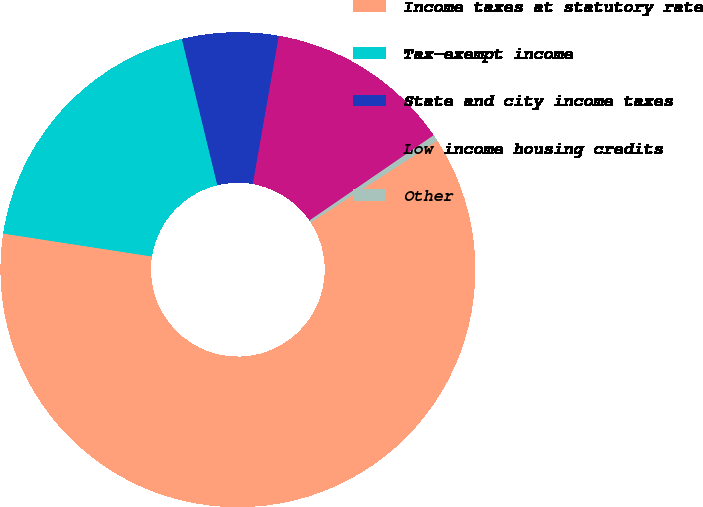Convert chart to OTSL. <chart><loc_0><loc_0><loc_500><loc_500><pie_chart><fcel>Income taxes at statutory rate<fcel>Tax-exempt income<fcel>State and city income taxes<fcel>Low income housing credits<fcel>Other<nl><fcel>61.58%<fcel>18.78%<fcel>6.55%<fcel>12.66%<fcel>0.43%<nl></chart> 